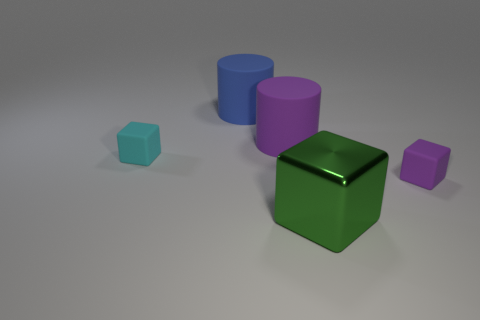Add 2 tiny purple blocks. How many objects exist? 7 Subtract all cubes. How many objects are left? 2 Add 3 large rubber cylinders. How many large rubber cylinders are left? 5 Add 5 rubber blocks. How many rubber blocks exist? 7 Subtract 0 cyan balls. How many objects are left? 5 Subtract all small gray things. Subtract all tiny cubes. How many objects are left? 3 